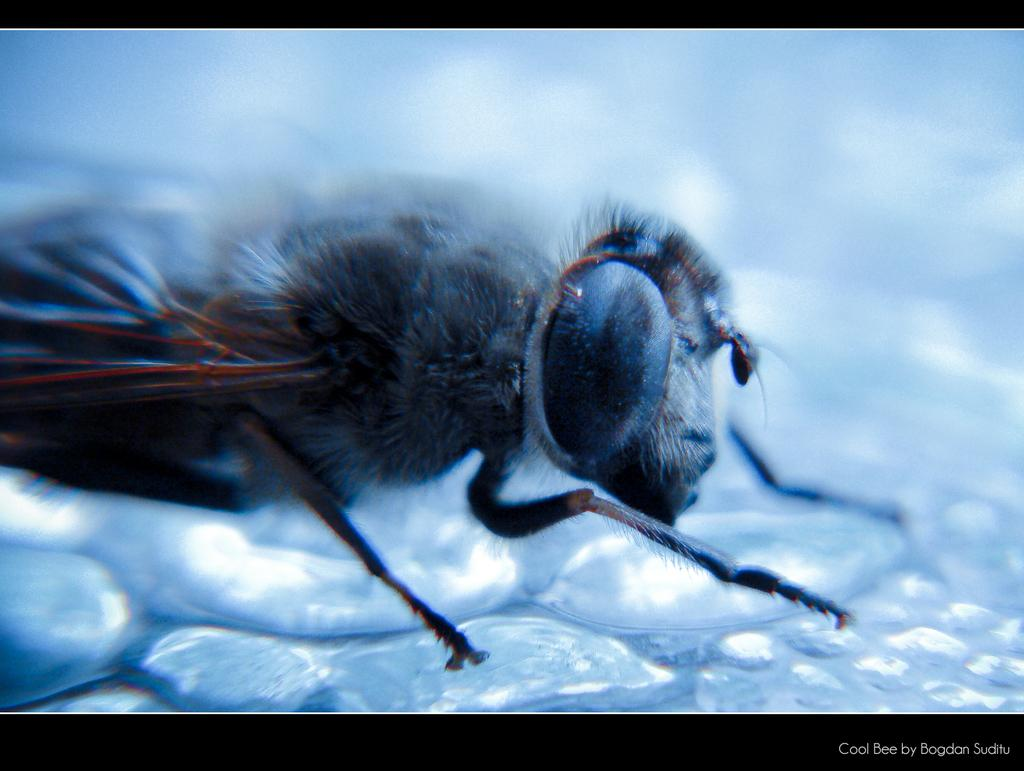What type of creature can be seen in the image? There is an insect in the image. Where is the insect located in the image? The insect is towards the left side of the image. What is visible on the ground in the image? There is water on the ground in the image. What can be found at the bottom of the image? There is text at the bottom of the image. How does the insect demonstrate its muscle strength in the image? The image does not show the insect demonstrating its muscle strength, as insects do not have muscles like humans. 